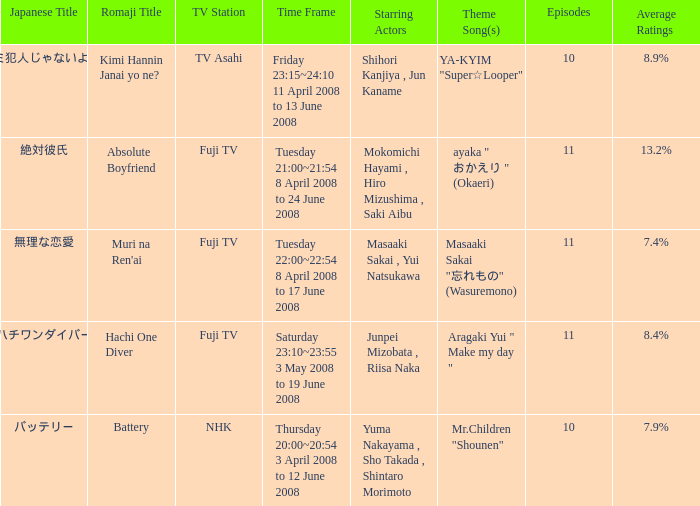Who were the starting actors in the time frame of  tuesday 22:00~22:54 8 april 2008 to 17 june 2008? Masaaki Sakai , Yui Natsukawa. Could you parse the entire table as a dict? {'header': ['Japanese Title', 'Romaji Title', 'TV Station', 'Time Frame', 'Starring Actors', 'Theme Song(s)', 'Episodes', 'Average Ratings'], 'rows': [['キミ犯人じゃないよね?', 'Kimi Hannin Janai yo ne?', 'TV Asahi', 'Friday 23:15~24:10 11 April 2008 to 13 June 2008', 'Shihori Kanjiya , Jun Kaname', 'YA-KYIM "Super☆Looper"', '10', '8.9%'], ['絶対彼氏', 'Absolute Boyfriend', 'Fuji TV', 'Tuesday 21:00~21:54 8 April 2008 to 24 June 2008', 'Mokomichi Hayami , Hiro Mizushima , Saki Aibu', 'ayaka " おかえり " (Okaeri)', '11', '13.2%'], ['無理な恋愛', "Muri na Ren'ai", 'Fuji TV', 'Tuesday 22:00~22:54 8 April 2008 to 17 June 2008', 'Masaaki Sakai , Yui Natsukawa', 'Masaaki Sakai "忘れもの" (Wasuremono)', '11', '7.4%'], ['ハチワンダイバー', 'Hachi One Diver', 'Fuji TV', 'Saturday 23:10~23:55 3 May 2008 to 19 June 2008', 'Junpei Mizobata , Riisa Naka', 'Aragaki Yui " Make my day "', '11', '8.4%'], ['バッテリー', 'Battery', 'NHK', 'Thursday 20:00~20:54 3 April 2008 to 12 June 2008', 'Yuma Nakayama , Sho Takada , Shintaro Morimoto', 'Mr.Children "Shounen"', '10', '7.9%']]} 